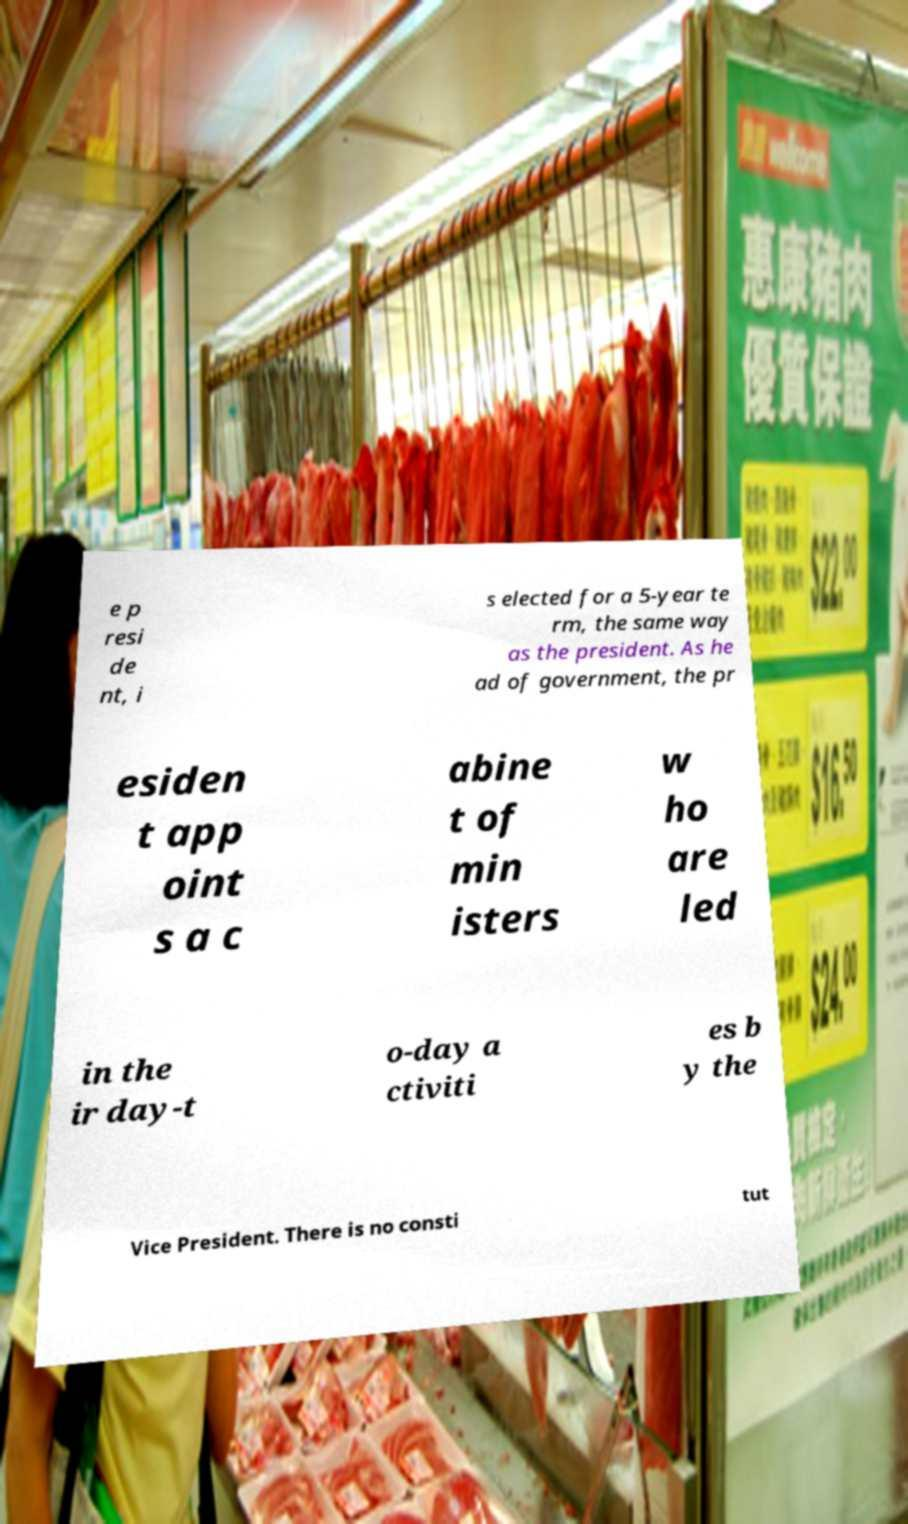I need the written content from this picture converted into text. Can you do that? e p resi de nt, i s elected for a 5-year te rm, the same way as the president. As he ad of government, the pr esiden t app oint s a c abine t of min isters w ho are led in the ir day-t o-day a ctiviti es b y the Vice President. There is no consti tut 